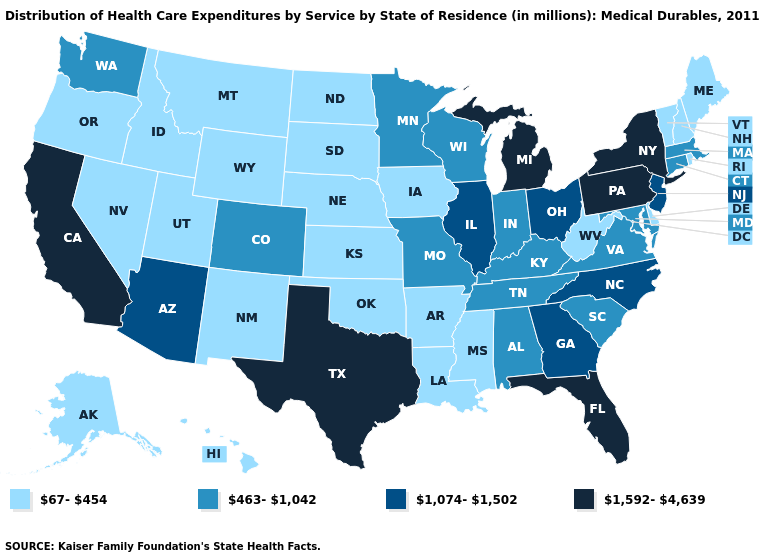What is the value of Vermont?
Keep it brief. 67-454. Does the map have missing data?
Be succinct. No. Name the states that have a value in the range 67-454?
Short answer required. Alaska, Arkansas, Delaware, Hawaii, Idaho, Iowa, Kansas, Louisiana, Maine, Mississippi, Montana, Nebraska, Nevada, New Hampshire, New Mexico, North Dakota, Oklahoma, Oregon, Rhode Island, South Dakota, Utah, Vermont, West Virginia, Wyoming. What is the highest value in the MidWest ?
Be succinct. 1,592-4,639. Name the states that have a value in the range 67-454?
Short answer required. Alaska, Arkansas, Delaware, Hawaii, Idaho, Iowa, Kansas, Louisiana, Maine, Mississippi, Montana, Nebraska, Nevada, New Hampshire, New Mexico, North Dakota, Oklahoma, Oregon, Rhode Island, South Dakota, Utah, Vermont, West Virginia, Wyoming. Which states hav the highest value in the West?
Give a very brief answer. California. What is the lowest value in the West?
Keep it brief. 67-454. Name the states that have a value in the range 67-454?
Write a very short answer. Alaska, Arkansas, Delaware, Hawaii, Idaho, Iowa, Kansas, Louisiana, Maine, Mississippi, Montana, Nebraska, Nevada, New Hampshire, New Mexico, North Dakota, Oklahoma, Oregon, Rhode Island, South Dakota, Utah, Vermont, West Virginia, Wyoming. What is the value of Kansas?
Keep it brief. 67-454. What is the lowest value in the USA?
Answer briefly. 67-454. Does Nebraska have the lowest value in the MidWest?
Be succinct. Yes. What is the value of Kansas?
Concise answer only. 67-454. Name the states that have a value in the range 463-1,042?
Quick response, please. Alabama, Colorado, Connecticut, Indiana, Kentucky, Maryland, Massachusetts, Minnesota, Missouri, South Carolina, Tennessee, Virginia, Washington, Wisconsin. Name the states that have a value in the range 67-454?
Write a very short answer. Alaska, Arkansas, Delaware, Hawaii, Idaho, Iowa, Kansas, Louisiana, Maine, Mississippi, Montana, Nebraska, Nevada, New Hampshire, New Mexico, North Dakota, Oklahoma, Oregon, Rhode Island, South Dakota, Utah, Vermont, West Virginia, Wyoming. What is the value of Virginia?
Short answer required. 463-1,042. 